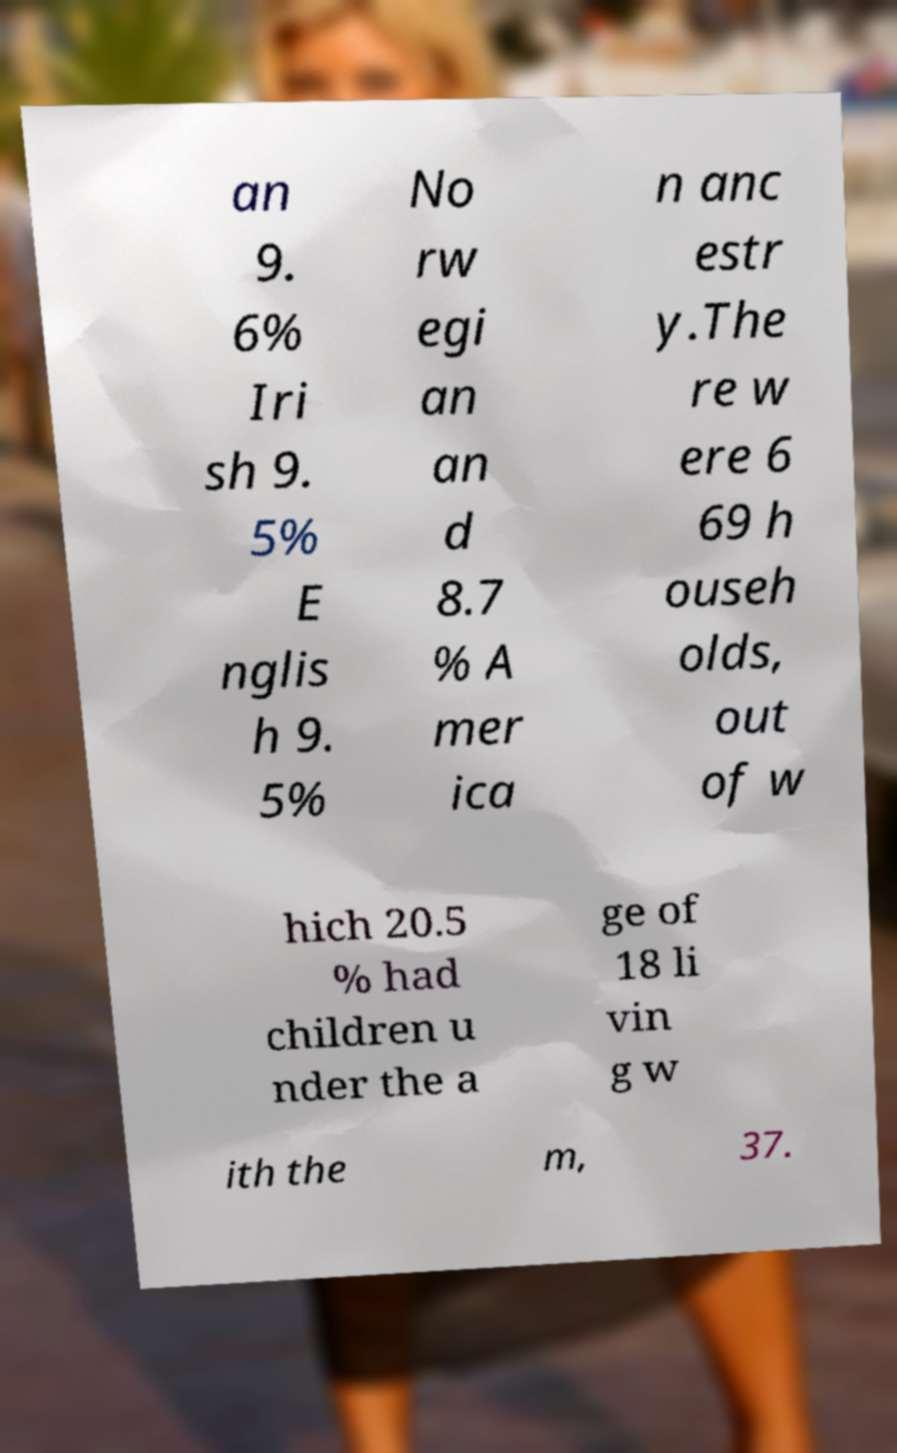Can you accurately transcribe the text from the provided image for me? an 9. 6% Iri sh 9. 5% E nglis h 9. 5% No rw egi an an d 8.7 % A mer ica n anc estr y.The re w ere 6 69 h ouseh olds, out of w hich 20.5 % had children u nder the a ge of 18 li vin g w ith the m, 37. 